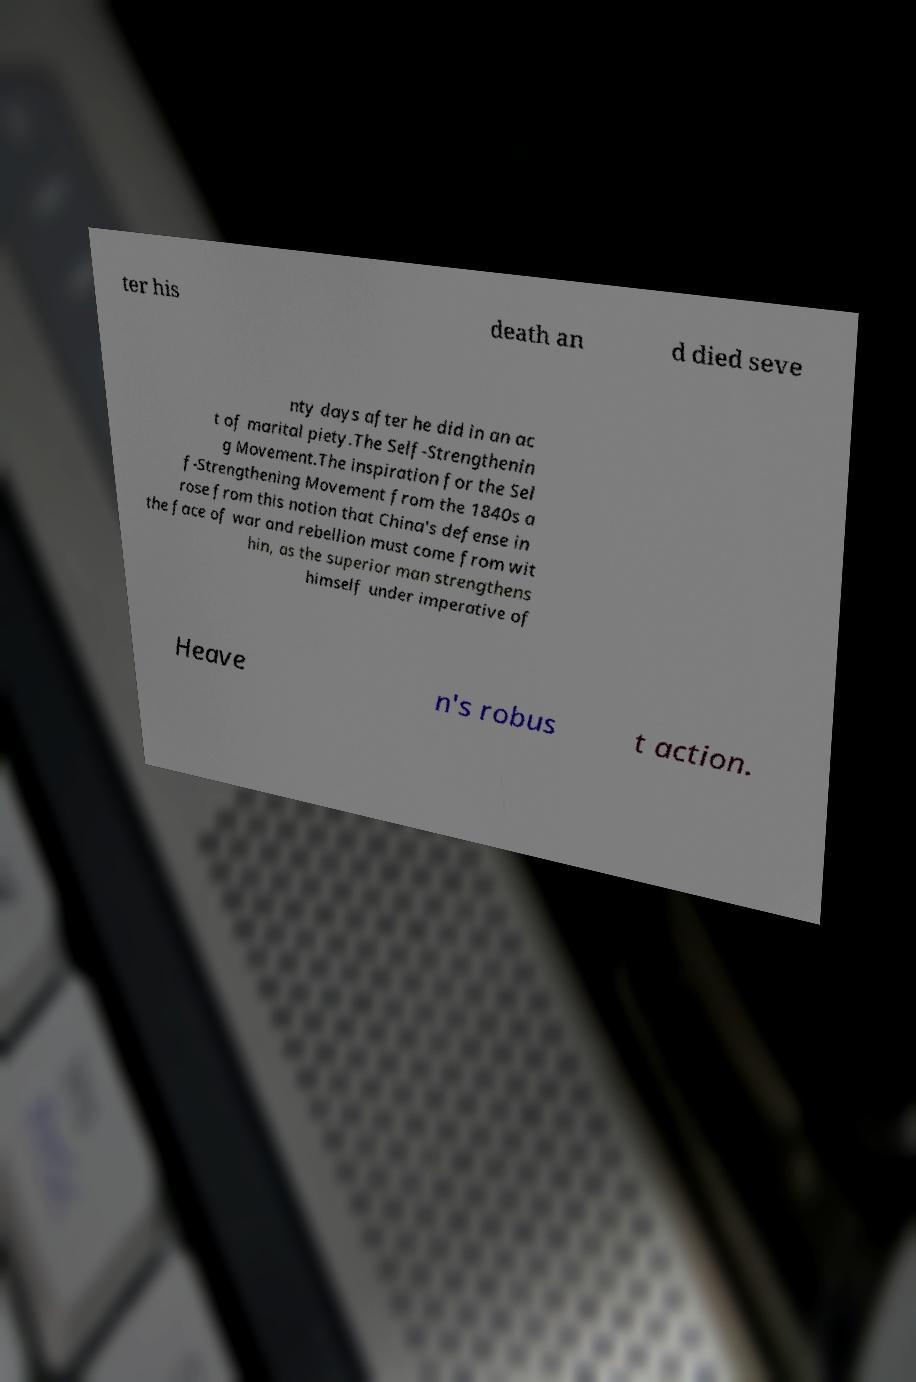Can you accurately transcribe the text from the provided image for me? ter his death an d died seve nty days after he did in an ac t of marital piety.The Self-Strengthenin g Movement.The inspiration for the Sel f-Strengthening Movement from the 1840s a rose from this notion that China's defense in the face of war and rebellion must come from wit hin, as the superior man strengthens himself under imperative of Heave n's robus t action. 